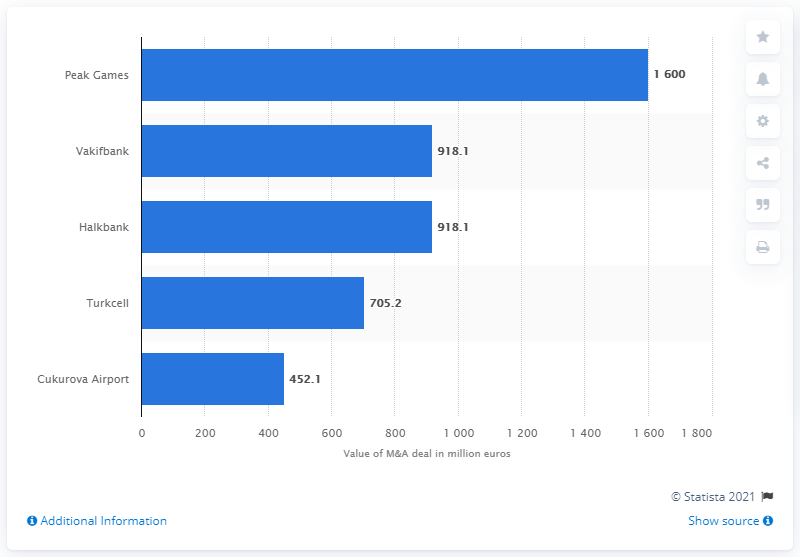Mention a couple of crucial points in this snapshot. The acquisition of Peak Games in 2020 is estimated to have cost $1,600. The Turkish Wealth Fund paid 918.1 million dollars for Halkbank. 